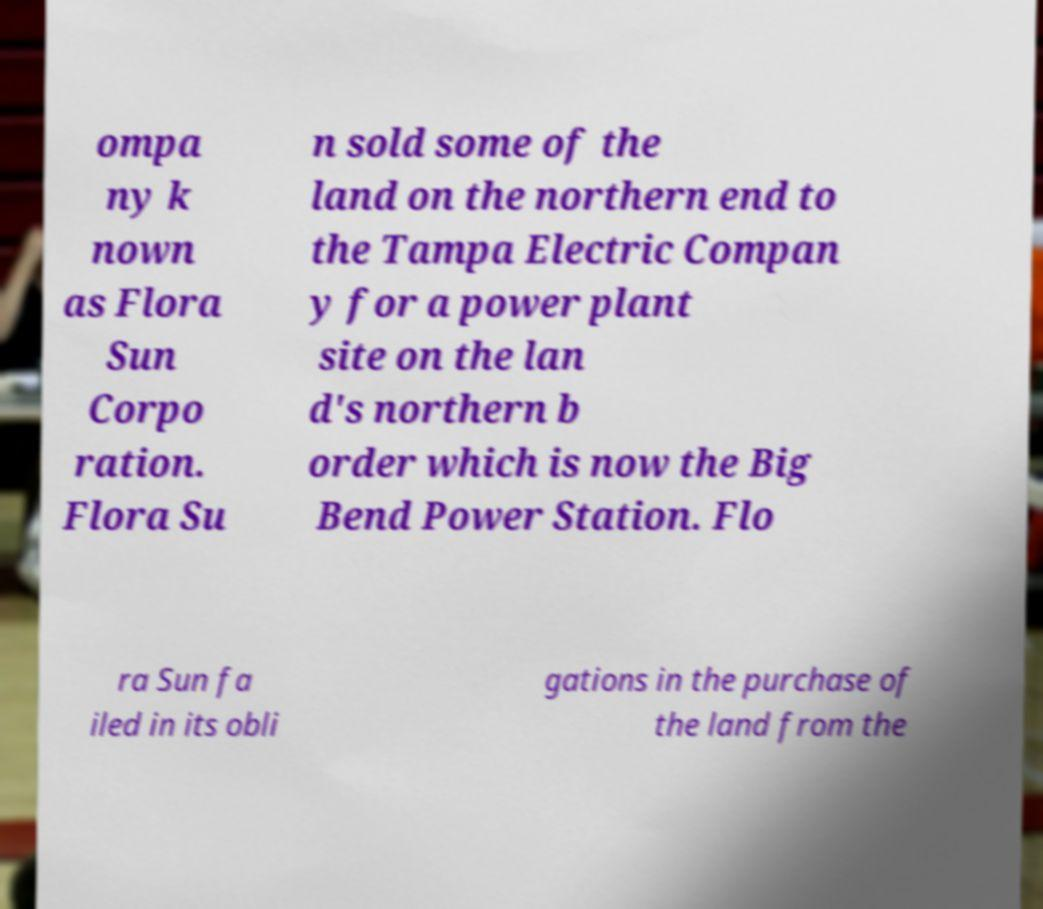Can you accurately transcribe the text from the provided image for me? ompa ny k nown as Flora Sun Corpo ration. Flora Su n sold some of the land on the northern end to the Tampa Electric Compan y for a power plant site on the lan d's northern b order which is now the Big Bend Power Station. Flo ra Sun fa iled in its obli gations in the purchase of the land from the 